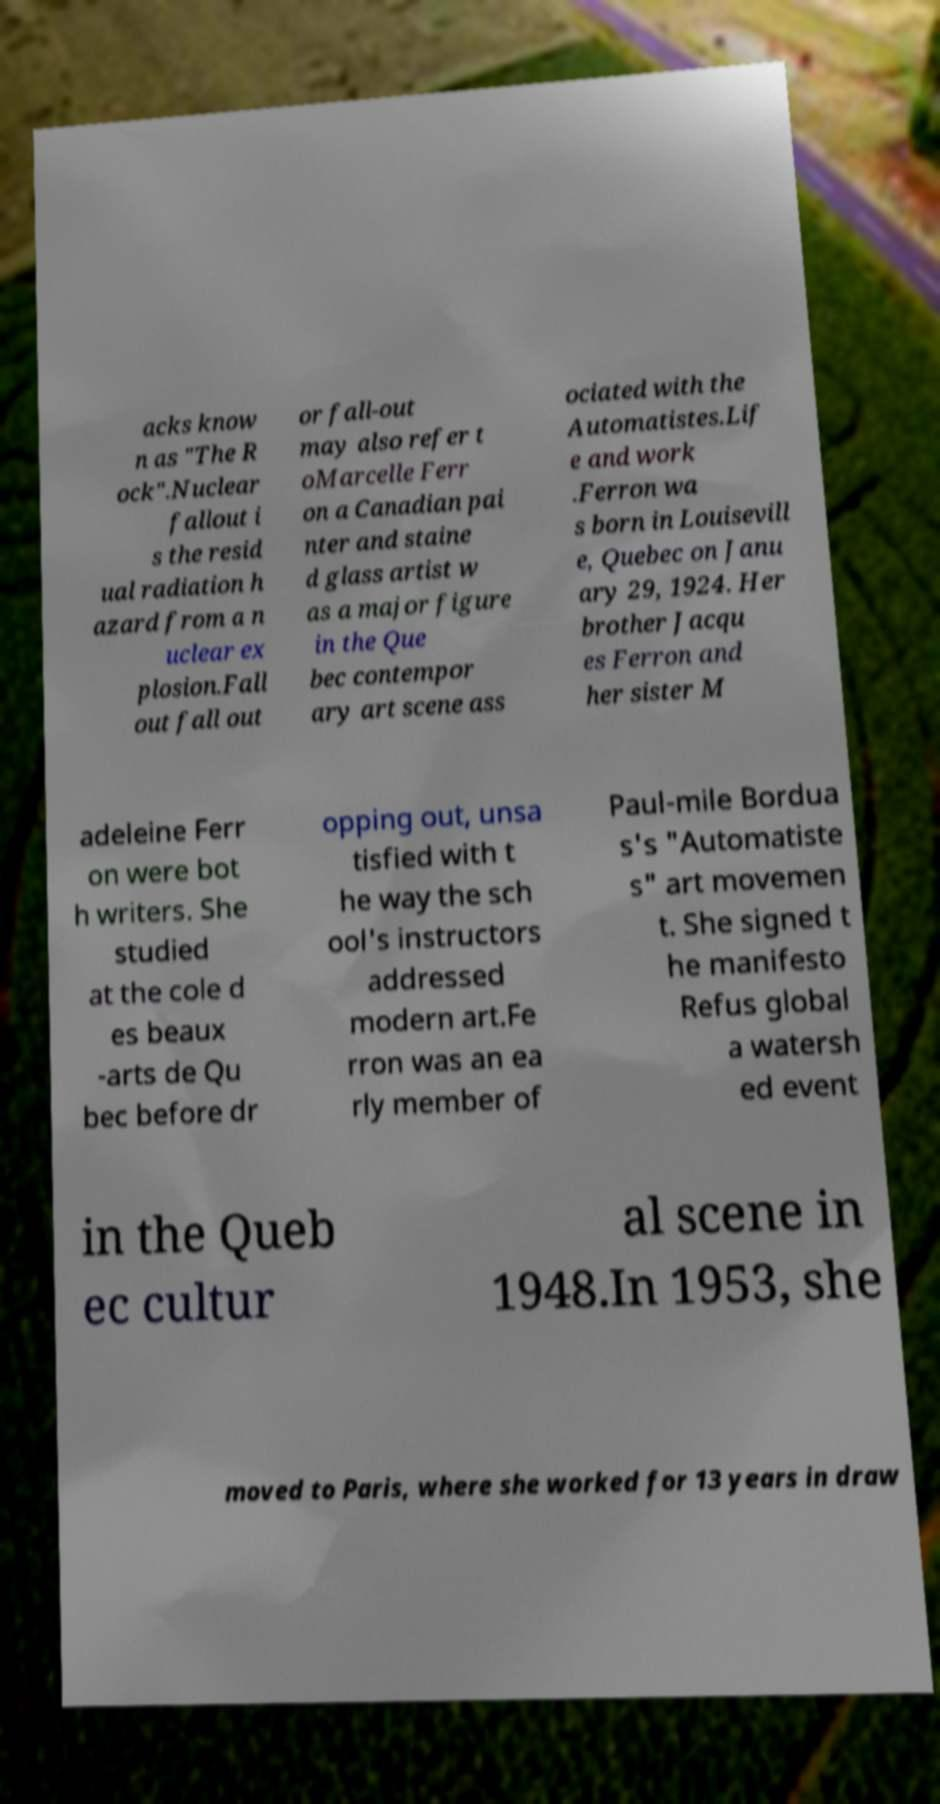Could you assist in decoding the text presented in this image and type it out clearly? acks know n as "The R ock".Nuclear fallout i s the resid ual radiation h azard from a n uclear ex plosion.Fall out fall out or fall-out may also refer t oMarcelle Ferr on a Canadian pai nter and staine d glass artist w as a major figure in the Que bec contempor ary art scene ass ociated with the Automatistes.Lif e and work .Ferron wa s born in Louisevill e, Quebec on Janu ary 29, 1924. Her brother Jacqu es Ferron and her sister M adeleine Ferr on were bot h writers. She studied at the cole d es beaux -arts de Qu bec before dr opping out, unsa tisfied with t he way the sch ool's instructors addressed modern art.Fe rron was an ea rly member of Paul-mile Bordua s's "Automatiste s" art movemen t. She signed t he manifesto Refus global a watersh ed event in the Queb ec cultur al scene in 1948.In 1953, she moved to Paris, where she worked for 13 years in draw 